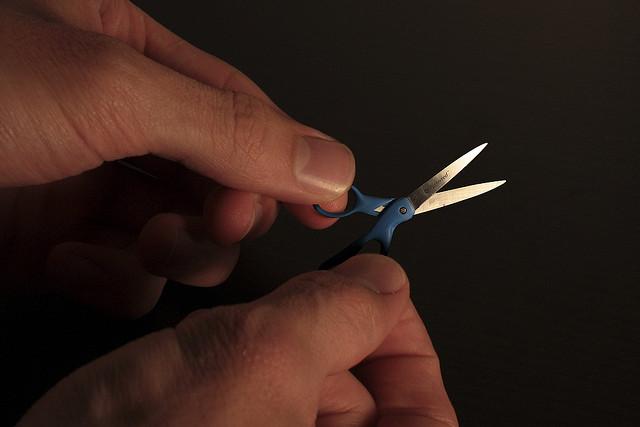How is the picture?
Quick response, please. Small scissors. What are they exchanging?
Keep it brief. Scissors. Is this a man or woman that is holding the scissors?
Keep it brief. Man. What can you cut with these?
Short answer required. Thread. What color are the handles?
Be succinct. Blue. What color is the handle of the scissors?
Quick response, please. Blue. 